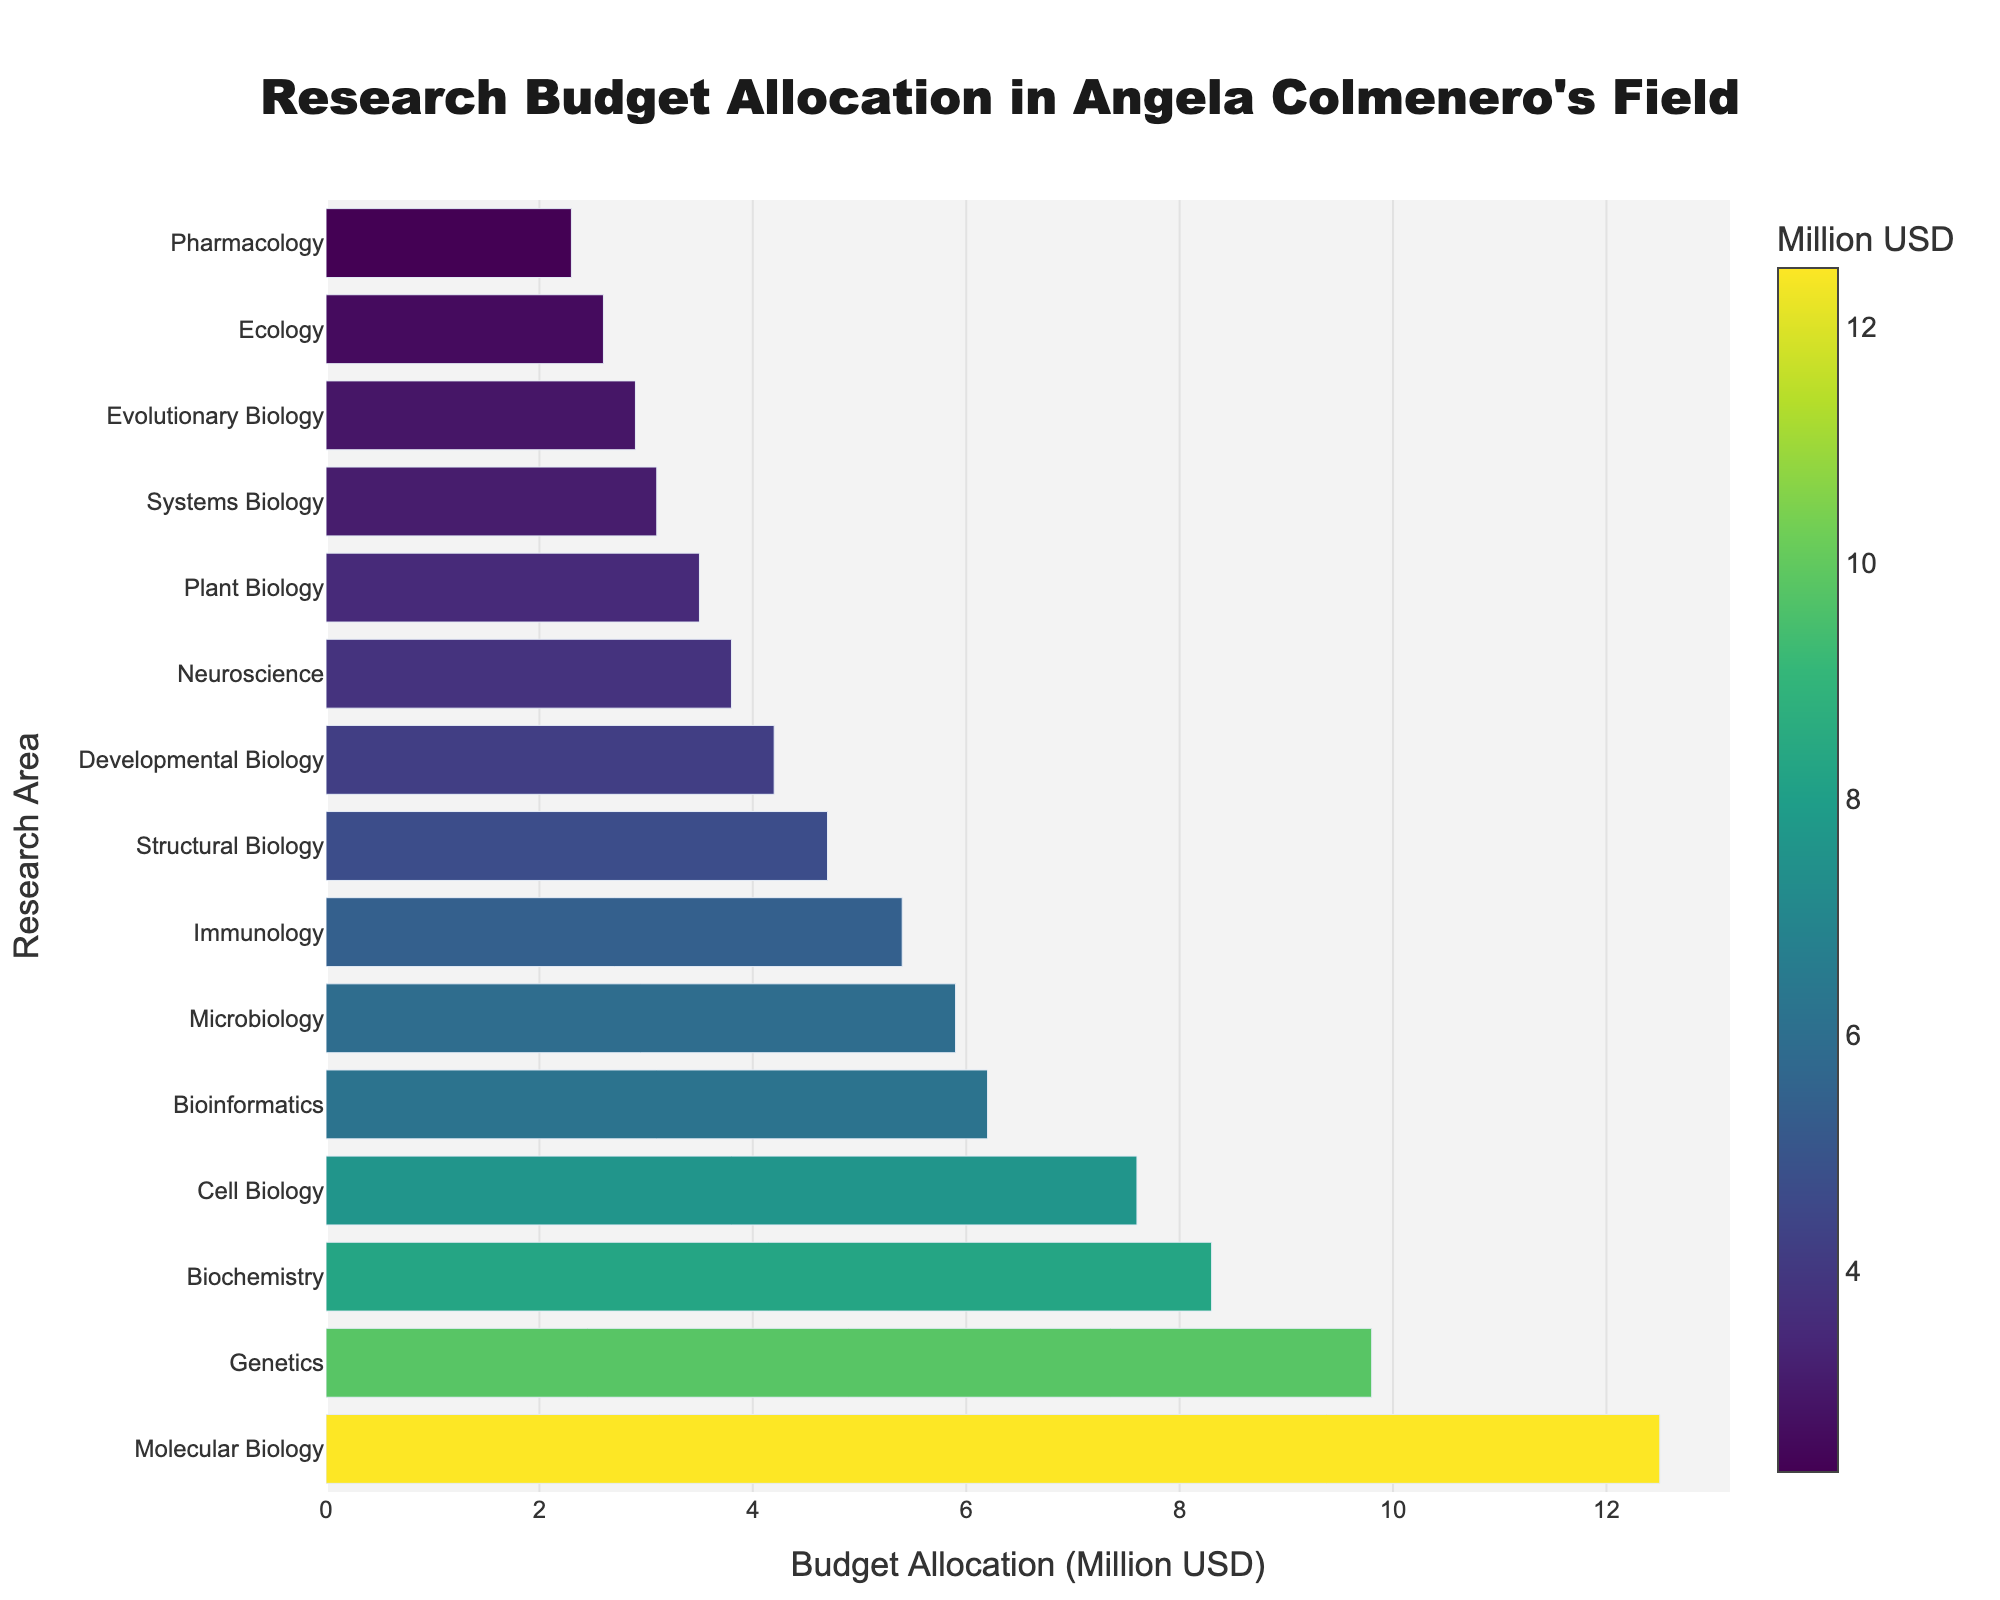Which research area has the highest budget allocation? The research area with the highest budget allocation will appear at the top of the bar chart, where the length of the bar is the longest. In this case, the longest bar represents Molecular Biology.
Answer: Molecular Biology What is the total budget allocated for Genetics, Biochemistry, and Cell Biology? To find the total budget, sum the budgets for Genetics, Biochemistry, and Cell Biology. From the figure, Genetics has 9.8 million USD, Biochemistry has 8.3 million USD, and Cell Biology has 7.6 million USD. So, the total is 9.8 + 8.3 + 7.6 = 25.7 million USD.
Answer: 25.7 million USD How much more budget does Molecular Biology receive compared to Neuroscience? Find the budget allocation for Molecular Biology and Neuroscience and subtract the latter from the former. Molecular Biology has 12.5 million USD, and Neuroscience has 3.8 million USD. Therefore, the difference is 12.5 - 3.8 = 8.7 million USD.
Answer: 8.7 million USD What is the average budget allocation across all research areas? To calculate the average budget, sum all the budget allocations and divide by the number of research areas. Summing all allocations gives 84.8 million USD, and there are 15 research areas. Thus, the average is 84.8 / 15 = 5.65 million USD.
Answer: 5.65 million USD Which research area has the smallest budget allocation, and what is its amount? The research area with the smallest budget allocation will appear at the bottom of the bar chart, where the length of the bar is the shortest. In this case, the shortest bar represents Pharmacology, which has an amount of 2.3 million USD.
Answer: Pharmacology, 2.3 million USD Is the budget for Bioinformatics more or less than the average budget allocation? First, calculate the average budget allocation, which is 5.65 million USD. The budget for Bioinformatics is 6.2 million USD. Since 6.2 is greater than 5.65, Bioinformatics has a higher budget than the average.
Answer: More What is the combined budget for the top three research areas? Sum the budget allocations for the top three research areas. From the figure, the top three research areas are Molecular Biology (12.5 million USD), Genetics (9.8 million USD), and Biochemistry (8.3 million USD). So, the combined budget is 12.5 + 9.8 + 8.3 = 30.6 million USD.
Answer: 30.6 million USD Which research areas have a budget allocation greater than 5 million USD? Identify research areas from the chart whose budget allocations are greater than 5 million USD. The research areas meeting this criterion are Molecular Biology, Genetics, Biochemistry, Cell Biology, Bioinformatics, Microbiology, and Immunology.
Answer: Molecular Biology, Genetics, Biochemistry, Cell Biology, Bioinformatics, Microbiology, Immunology 